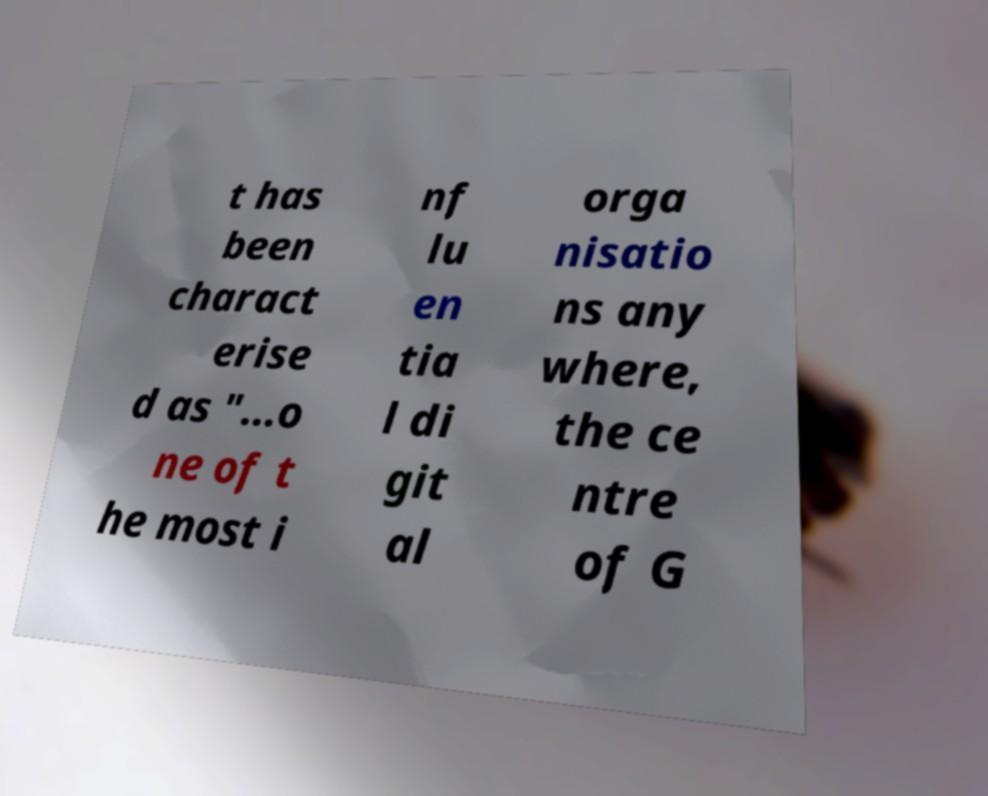For documentation purposes, I need the text within this image transcribed. Could you provide that? t has been charact erise d as "…o ne of t he most i nf lu en tia l di git al orga nisatio ns any where, the ce ntre of G 